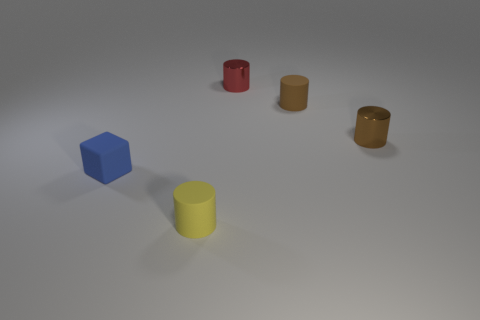How many other things are there of the same size as the yellow thing?
Keep it short and to the point. 4. There is a yellow matte cylinder; is it the same size as the matte cylinder behind the small yellow rubber thing?
Make the answer very short. Yes. The tiny blue object has what shape?
Offer a terse response. Cube. There is another shiny object that is the same shape as the tiny red thing; what color is it?
Give a very brief answer. Brown. What number of rubber cubes are in front of the matte object that is behind the tiny blue rubber object?
Your answer should be compact. 1. How many blocks are either yellow things or small shiny objects?
Ensure brevity in your answer.  0. Are any metal things visible?
Your answer should be compact. Yes. What size is the yellow rubber object that is the same shape as the brown shiny thing?
Your response must be concise. Small. There is a tiny matte thing that is behind the tiny metal thing that is in front of the small red metallic thing; what shape is it?
Offer a very short reply. Cylinder. What number of blue things are either metal things or tiny matte things?
Provide a short and direct response. 1. 